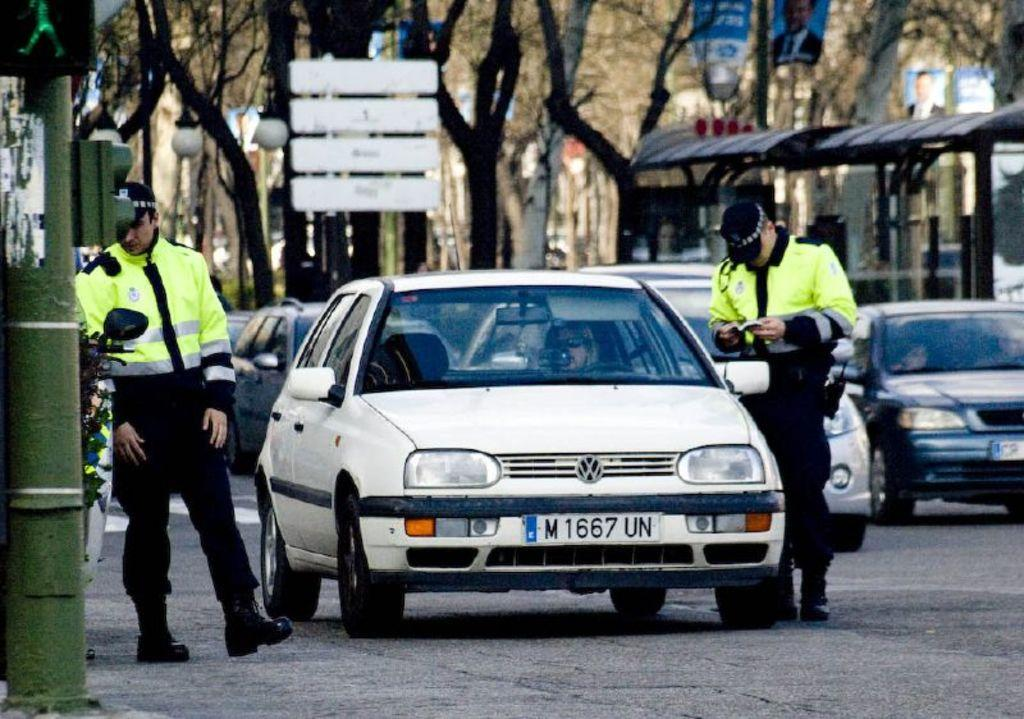How many people are standing on the road in the image? There are two persons standing on the road in the image. What else can be seen on the road besides the people? There are cars on the road. What can be seen in the background of the image? There are trees and a shed in the background of the image. What additional object is present in the image? There is a banner in the image. Can you describe another object in the image? There is a pole in the image. What type of straw is being used by the birds in the image? There are no birds present in the image, so there is no straw being used by them. Can you tell me the make and model of the airplane in the image? There is no airplane present in the image. 